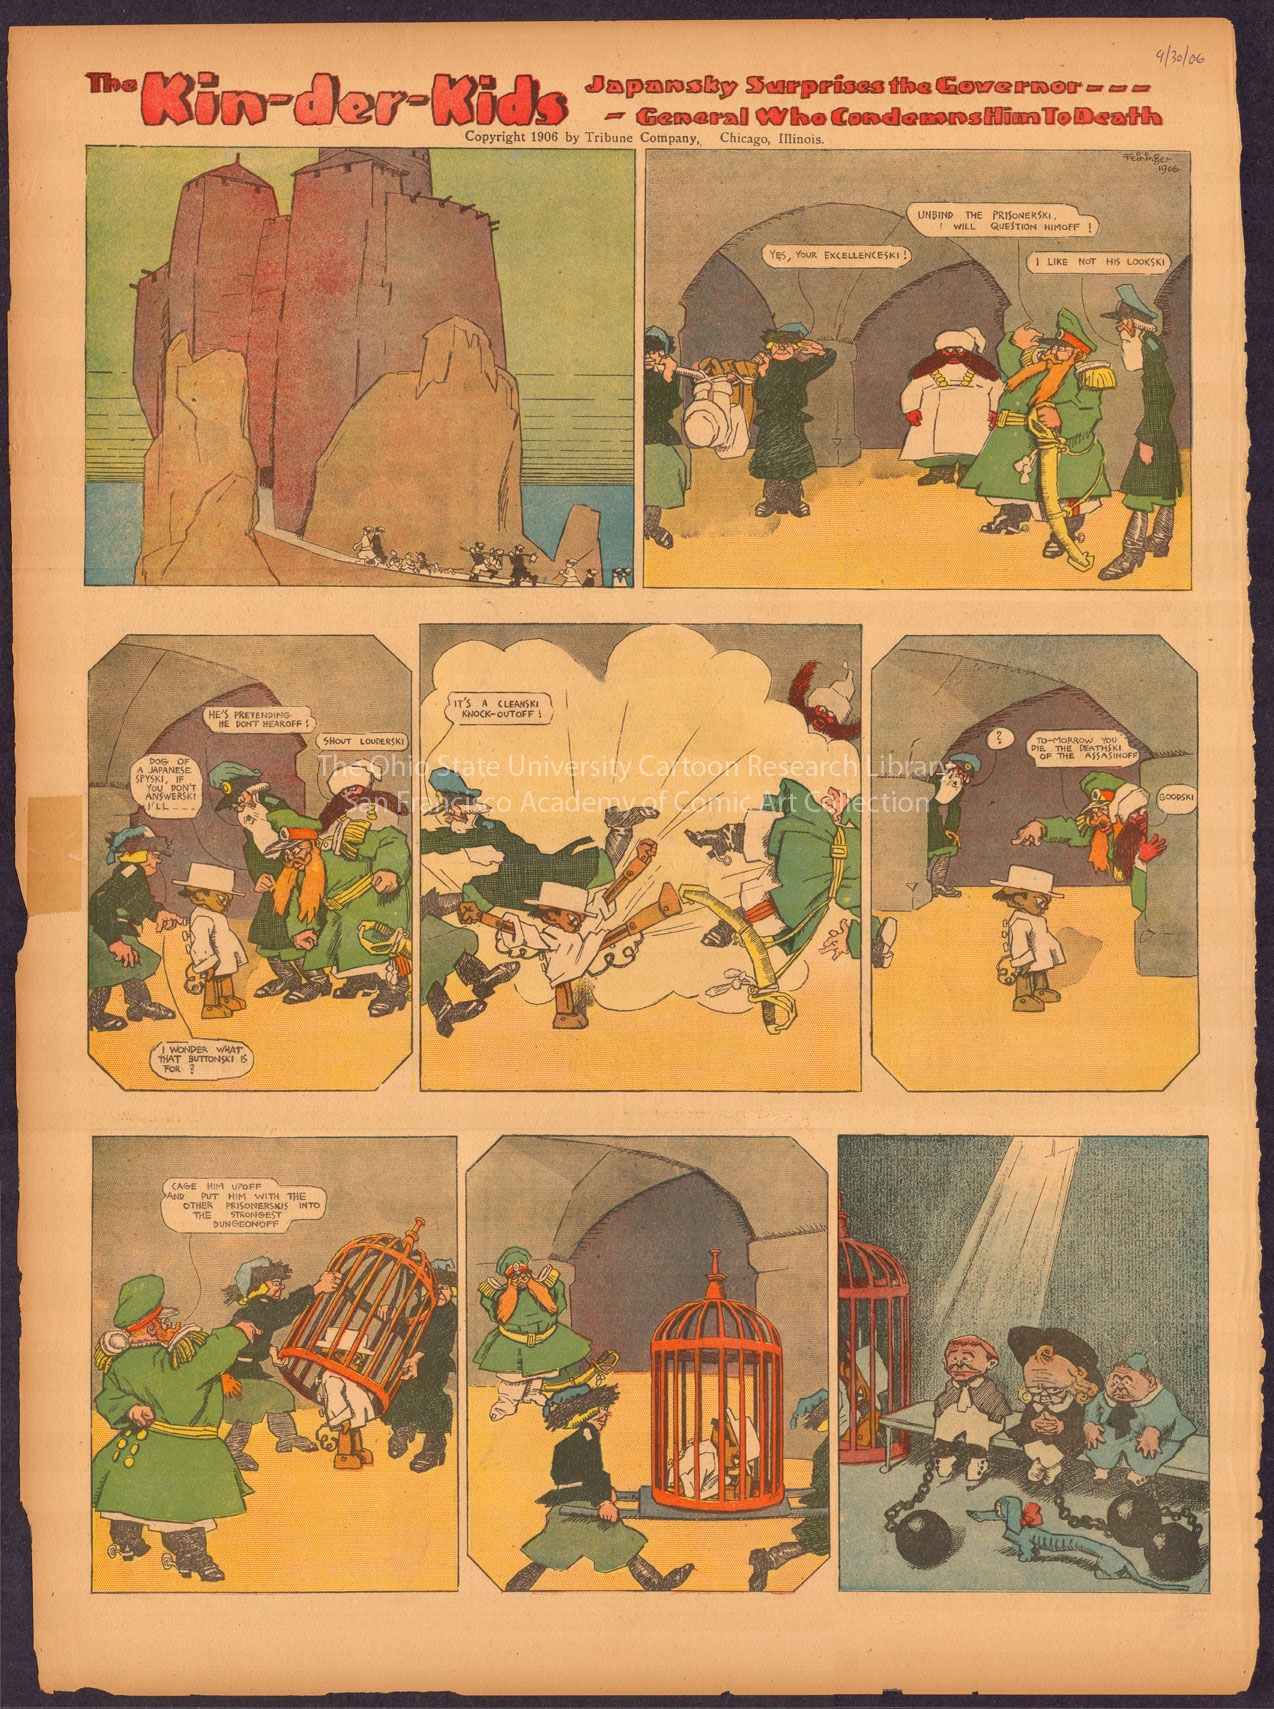What themes does this comic strip address? The 'Kin-der-Kids' comic strip explores themes of adventure, whimsy, and satire. The storylines are often fantastic and nonsensical, which was typical in the early development of comic strips as a form of escapism and humor. Additionally, there is an undercurrent of social and political satire, as seen in the titles and some of the key characters, reflecting contemporary events and sometimes subtly commenting on them. 